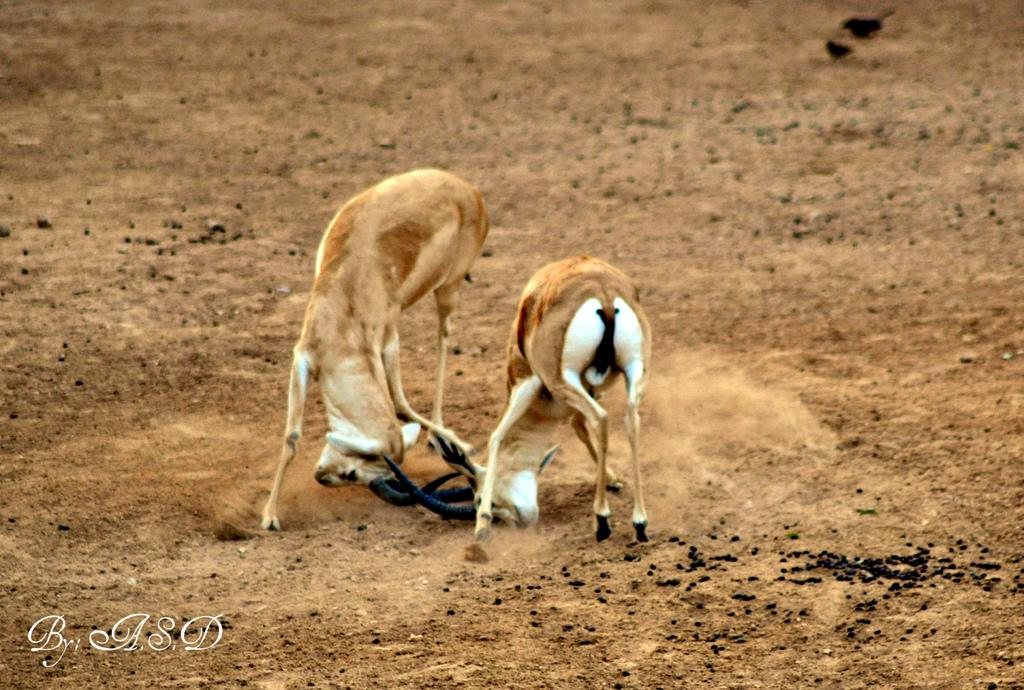What animals can be seen standing in the image? There are two deer standing in the image. What other living creatures are visible in the image? Birds are visible in the image. What type of terrain is depicted in the image? There is mud and dirt in the image. Where is the text located in the image? The text is at the bottom left of the image. What brand of toothpaste is being advertised in the image? There is no toothpaste or advertisement present in the image. What type of goat can be seen grazing in the image? There is no goat present in the image; only deer and birds are visible. 